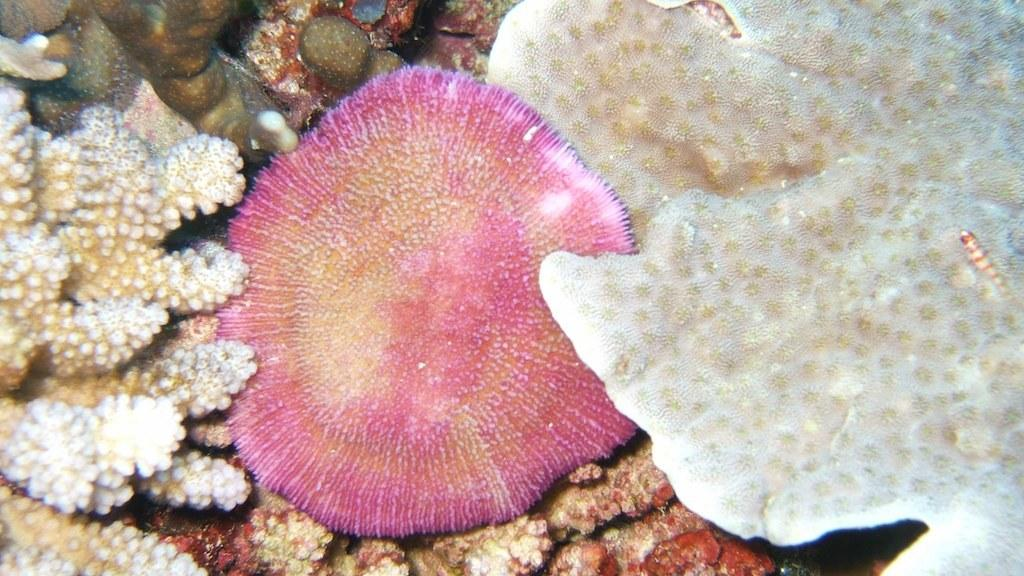What type of plants can be seen in the image? There are underwater plants in the image. What organization is responsible for managing the airport in the image? There is no airport present in the image, as it features underwater plants. 